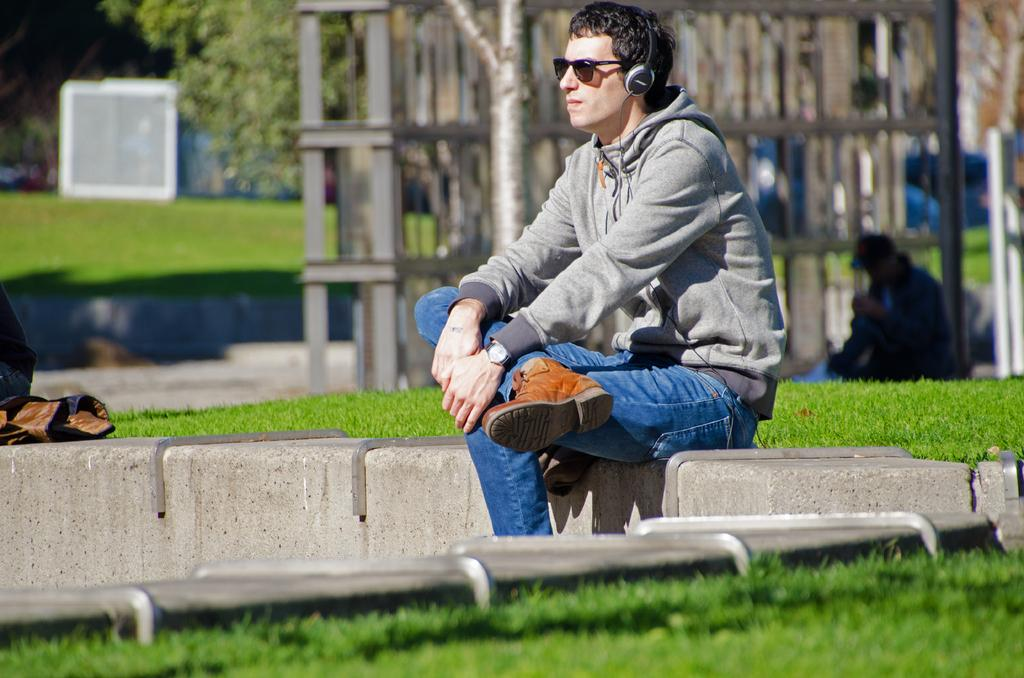What is the person in the image doing? The person is sitting in the park. Where is the person sitting in relation to the grass? The person is sitting in front of the grass. What is the person using to listen to something? The person is listening through headphones. What can be seen behind the person? There are materials behind the person. What type of natural elements are present in the park? There are trees in the park. What type of pie is the person holding in the image? There is no pie present in the image; the person is sitting and listening through headphones. 